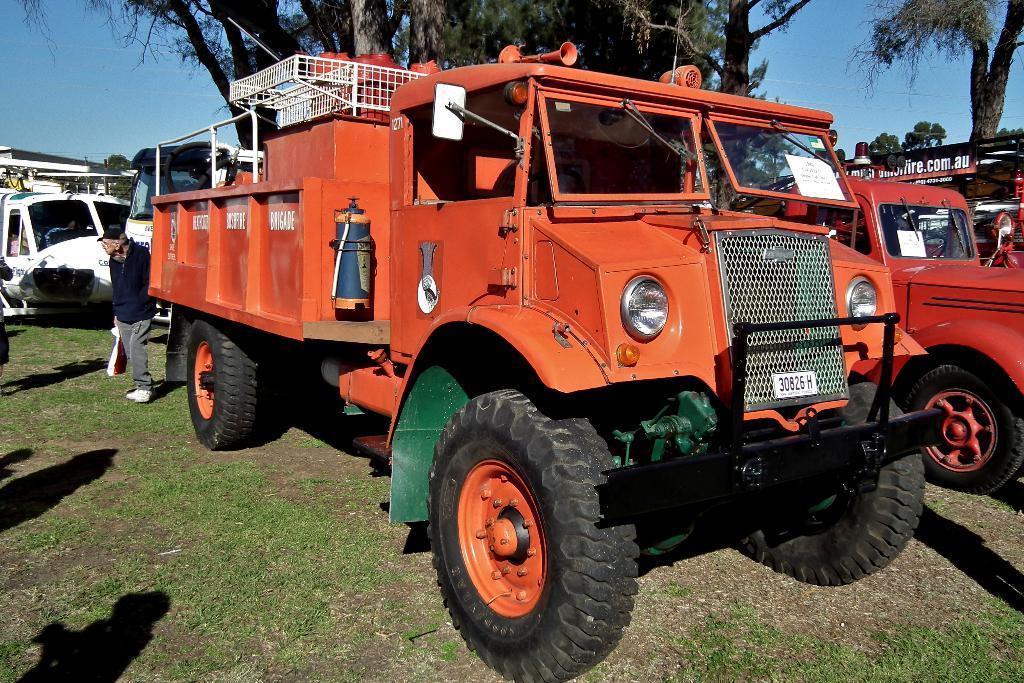How would you summarize this image in a sentence or two? In the foreground of the picture there are vehicles, grass and a person. In the middle of the picture there are trees. In the background it is sky. 